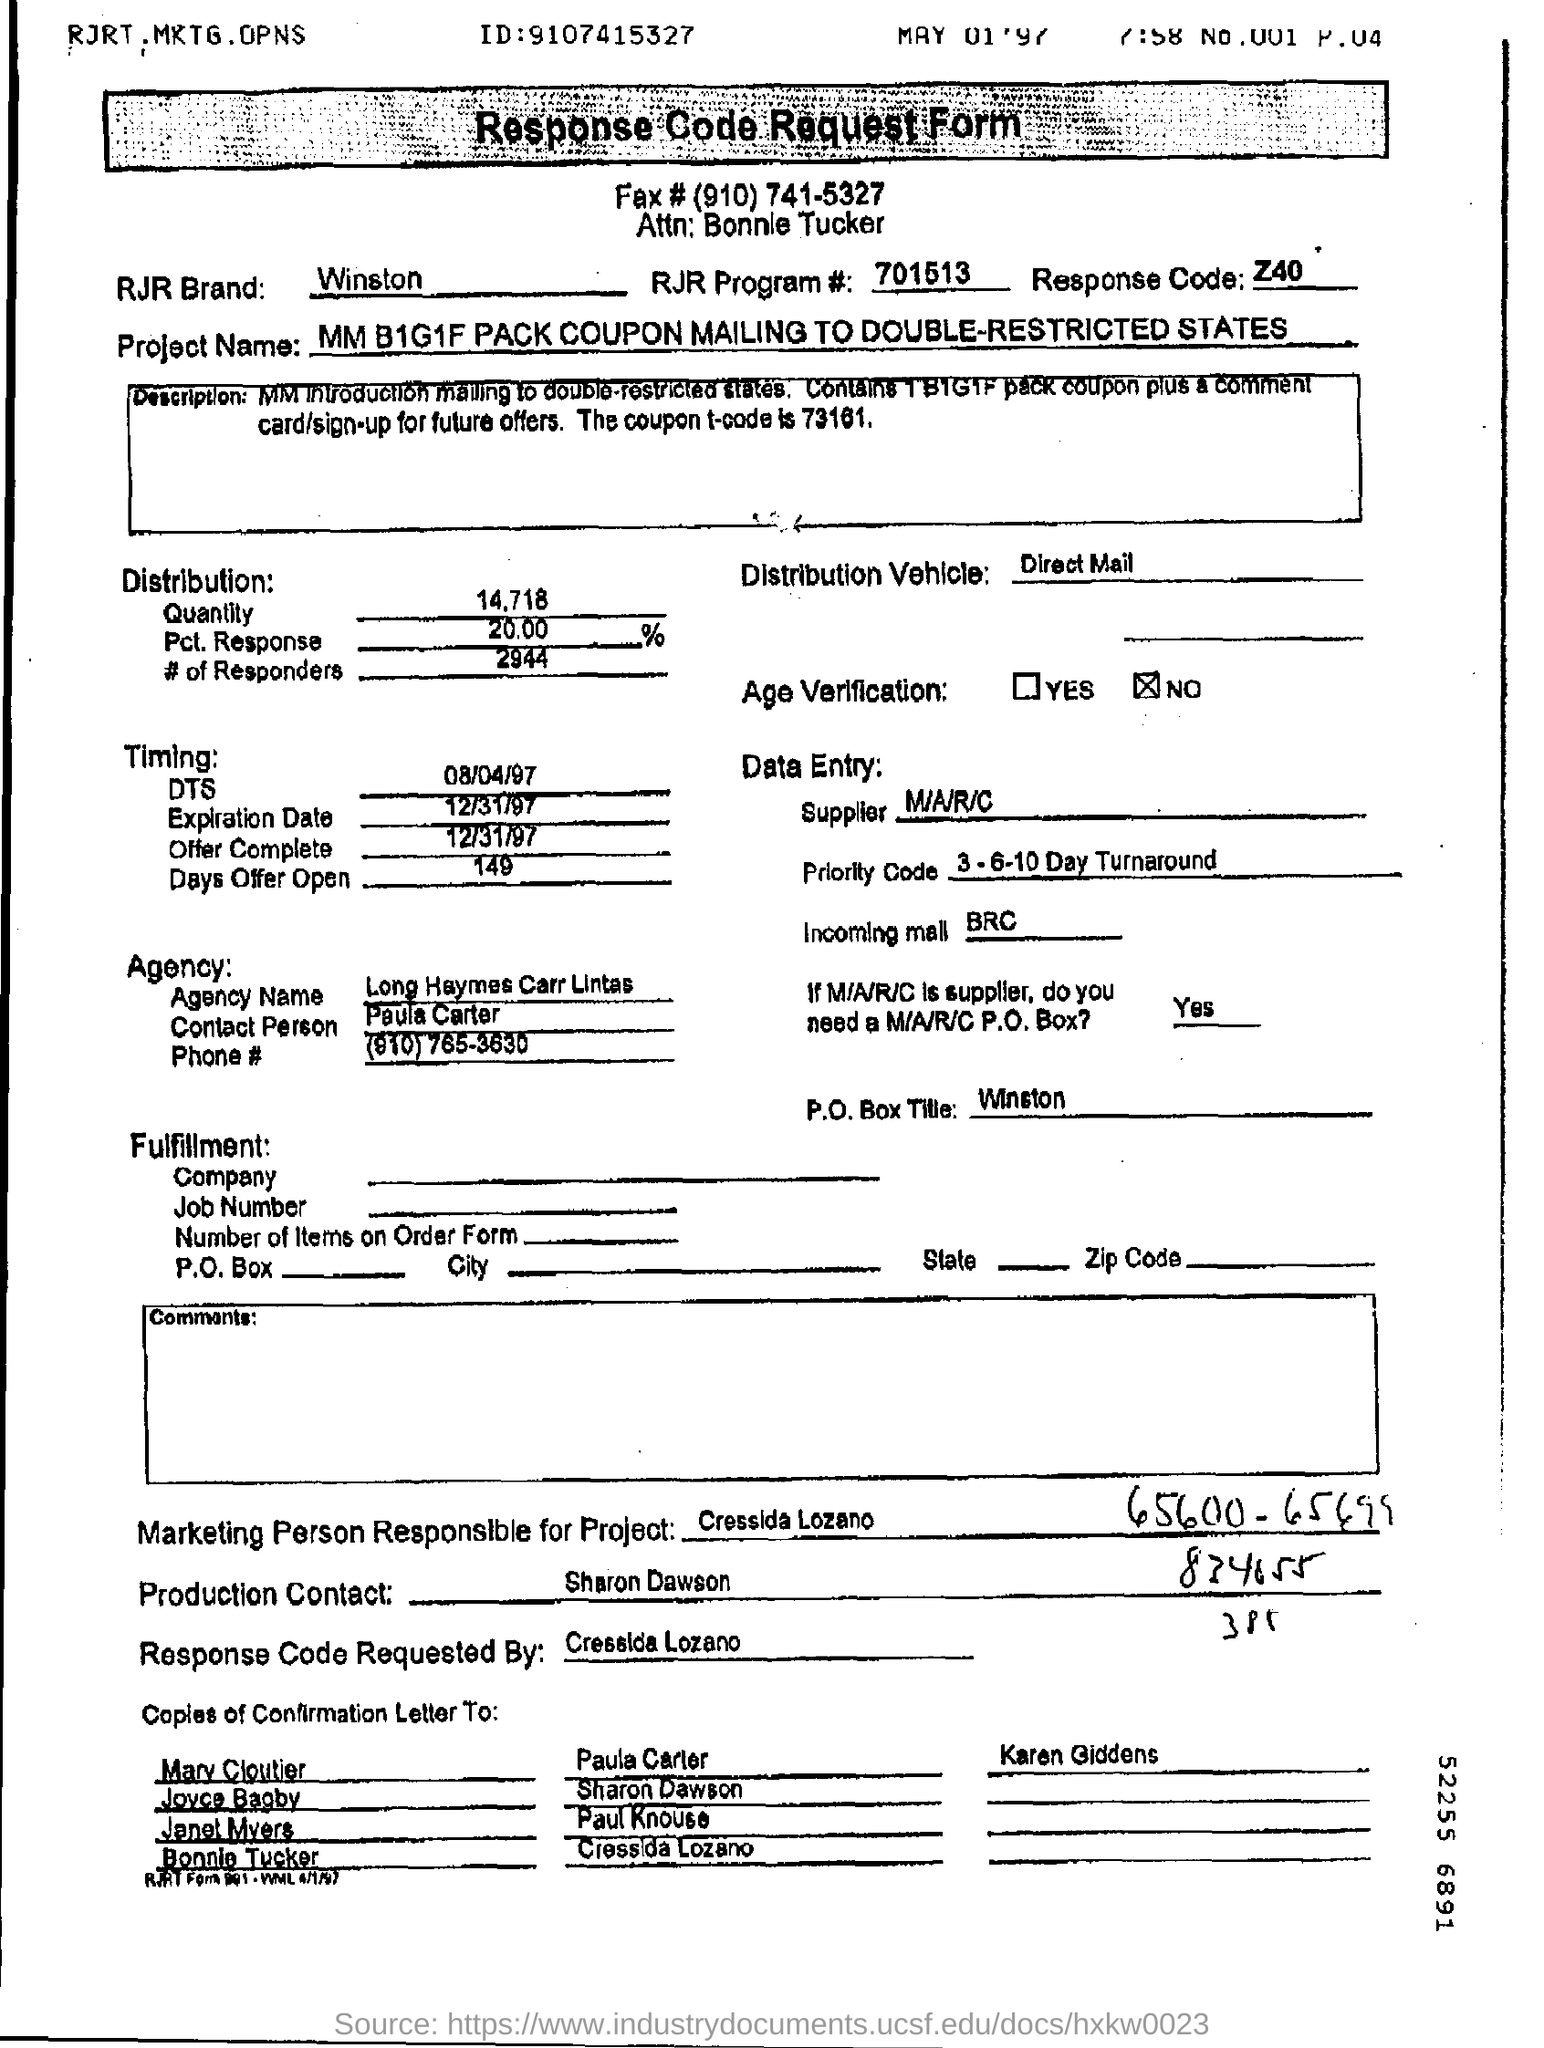What is the RJR Brand?
Provide a short and direct response. Winston. What is the Project Name?
Give a very brief answer. MM B1G1F PACK COUPON MAILING TO DOUBLE-RESTRICTED STATES. How many Responders are there in the Distrbution?
Ensure brevity in your answer.  2944. Who is the Production Contact?
Your answer should be compact. Sharon Dawson. 